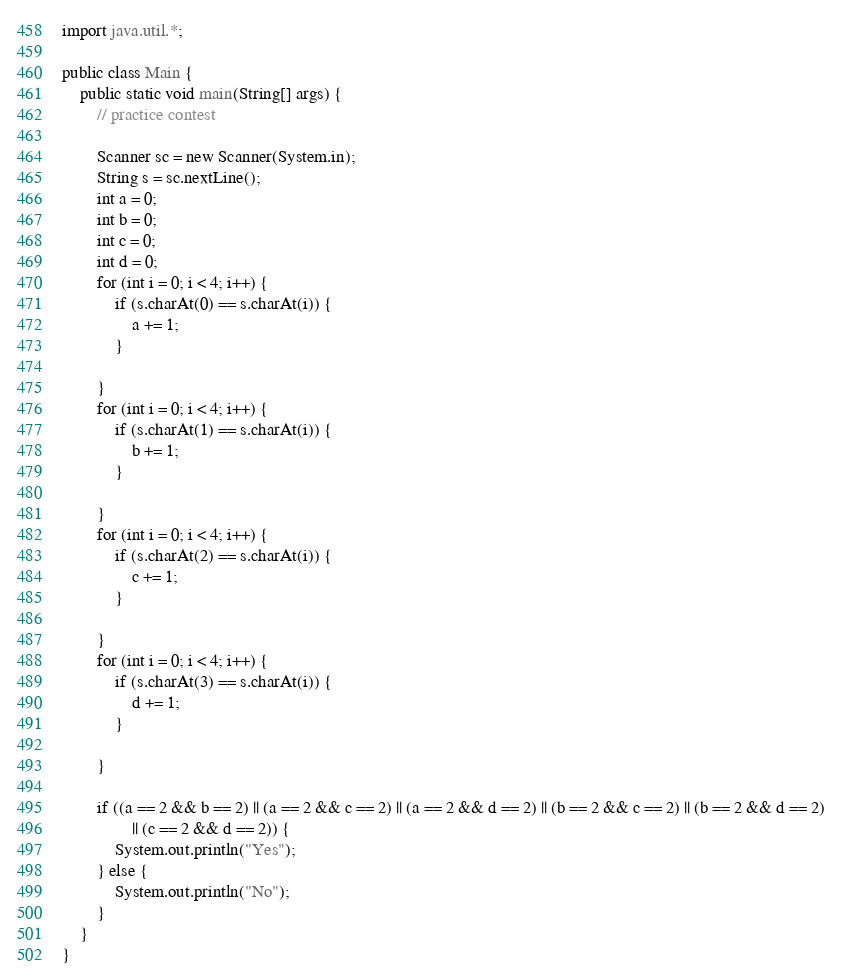Convert code to text. <code><loc_0><loc_0><loc_500><loc_500><_Java_>import java.util.*;

public class Main {
	public static void main(String[] args) {
		// practice contest

		Scanner sc = new Scanner(System.in);
		String s = sc.nextLine();
		int a = 0;
		int b = 0;
		int c = 0;
		int d = 0;
		for (int i = 0; i < 4; i++) {
			if (s.charAt(0) == s.charAt(i)) {
				a += 1;
			}

		}
		for (int i = 0; i < 4; i++) {
			if (s.charAt(1) == s.charAt(i)) {
				b += 1;
			}

		}
		for (int i = 0; i < 4; i++) {
			if (s.charAt(2) == s.charAt(i)) {
				c += 1;
			}

		}
		for (int i = 0; i < 4; i++) {
			if (s.charAt(3) == s.charAt(i)) {
				d += 1;
			}

		}

		if ((a == 2 && b == 2) || (a == 2 && c == 2) || (a == 2 && d == 2) || (b == 2 && c == 2) || (b == 2 && d == 2)
				|| (c == 2 && d == 2)) {
			System.out.println("Yes");
		} else {
			System.out.println("No");
		}
	}
}
</code> 